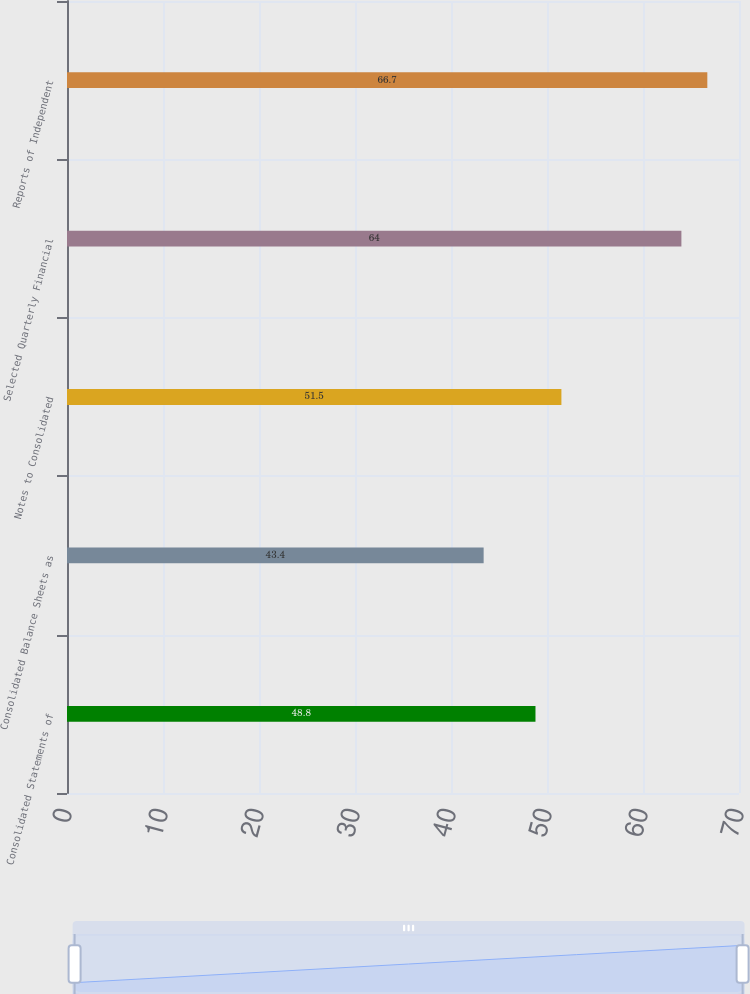Convert chart. <chart><loc_0><loc_0><loc_500><loc_500><bar_chart><fcel>Consolidated Statements of<fcel>Consolidated Balance Sheets as<fcel>Notes to Consolidated<fcel>Selected Quarterly Financial<fcel>Reports of Independent<nl><fcel>48.8<fcel>43.4<fcel>51.5<fcel>64<fcel>66.7<nl></chart> 